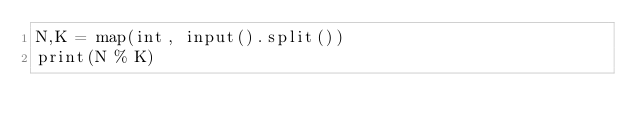<code> <loc_0><loc_0><loc_500><loc_500><_Python_>N,K = map(int, input().split())
print(N % K)</code> 